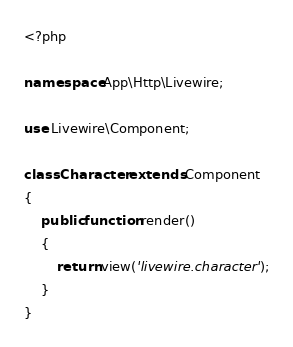<code> <loc_0><loc_0><loc_500><loc_500><_PHP_><?php

namespace App\Http\Livewire;

use Livewire\Component;

class Character extends Component
{
    public function render()
    {
        return view('livewire.character');
    }
}
</code> 